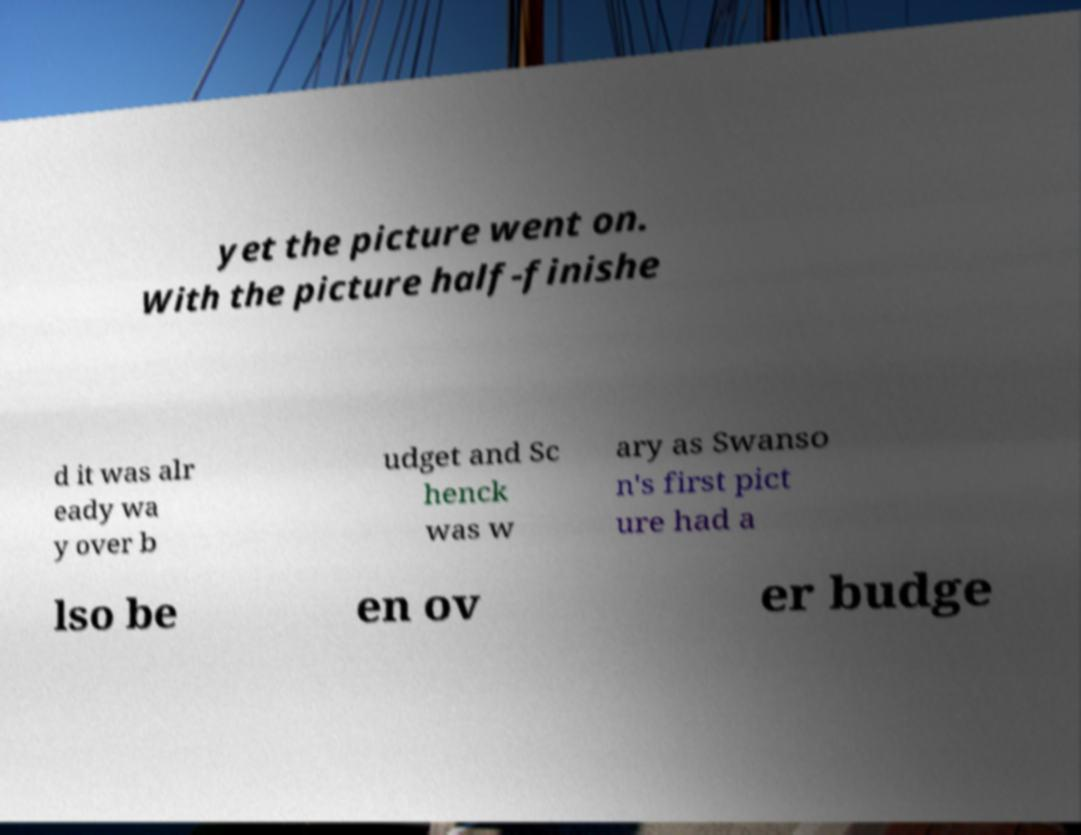Please read and relay the text visible in this image. What does it say? yet the picture went on. With the picture half-finishe d it was alr eady wa y over b udget and Sc henck was w ary as Swanso n's first pict ure had a lso be en ov er budge 